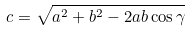<formula> <loc_0><loc_0><loc_500><loc_500>c = \sqrt { a ^ { 2 } + b ^ { 2 } - 2 a b \cos \gamma }</formula> 